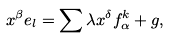<formula> <loc_0><loc_0><loc_500><loc_500>x ^ { \beta } e _ { l } = \sum \lambda x ^ { \delta } f _ { \alpha } ^ { k } + g ,</formula> 